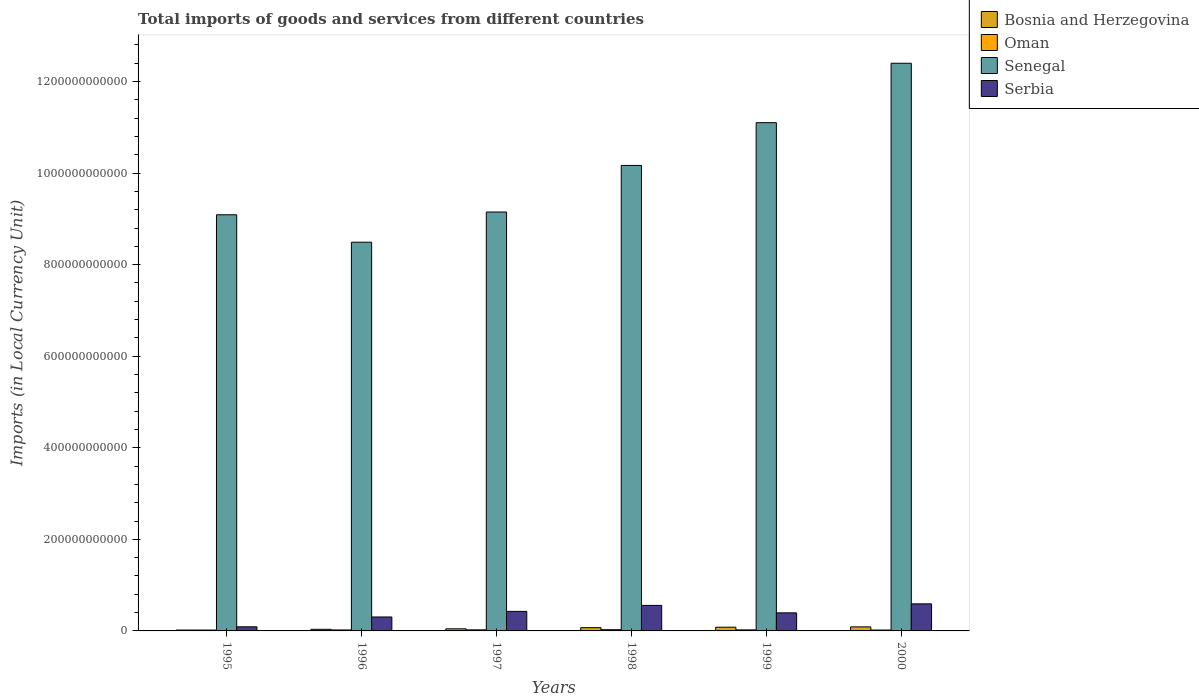How many different coloured bars are there?
Keep it short and to the point. 4. Are the number of bars on each tick of the X-axis equal?
Provide a short and direct response. Yes. How many bars are there on the 3rd tick from the left?
Offer a terse response. 4. What is the label of the 2nd group of bars from the left?
Offer a terse response. 1996. What is the Amount of goods and services imports in Bosnia and Herzegovina in 2000?
Make the answer very short. 8.83e+09. Across all years, what is the maximum Amount of goods and services imports in Senegal?
Make the answer very short. 1.24e+12. Across all years, what is the minimum Amount of goods and services imports in Bosnia and Herzegovina?
Your answer should be very brief. 1.91e+09. In which year was the Amount of goods and services imports in Serbia maximum?
Provide a short and direct response. 2000. In which year was the Amount of goods and services imports in Senegal minimum?
Provide a short and direct response. 1996. What is the total Amount of goods and services imports in Senegal in the graph?
Provide a succinct answer. 6.04e+12. What is the difference between the Amount of goods and services imports in Oman in 1997 and that in 1999?
Give a very brief answer. 8.10e+07. What is the difference between the Amount of goods and services imports in Serbia in 2000 and the Amount of goods and services imports in Bosnia and Herzegovina in 1999?
Make the answer very short. 5.10e+1. What is the average Amount of goods and services imports in Serbia per year?
Ensure brevity in your answer.  3.94e+1. In the year 1995, what is the difference between the Amount of goods and services imports in Serbia and Amount of goods and services imports in Oman?
Keep it short and to the point. 7.07e+09. What is the ratio of the Amount of goods and services imports in Oman in 1999 to that in 2000?
Your response must be concise. 1.17. Is the difference between the Amount of goods and services imports in Serbia in 1998 and 2000 greater than the difference between the Amount of goods and services imports in Oman in 1998 and 2000?
Offer a very short reply. No. What is the difference between the highest and the second highest Amount of goods and services imports in Serbia?
Offer a very short reply. 3.45e+09. What is the difference between the highest and the lowest Amount of goods and services imports in Senegal?
Ensure brevity in your answer.  3.91e+11. Is the sum of the Amount of goods and services imports in Serbia in 1997 and 1999 greater than the maximum Amount of goods and services imports in Oman across all years?
Keep it short and to the point. Yes. Is it the case that in every year, the sum of the Amount of goods and services imports in Oman and Amount of goods and services imports in Senegal is greater than the sum of Amount of goods and services imports in Serbia and Amount of goods and services imports in Bosnia and Herzegovina?
Your answer should be very brief. Yes. What does the 4th bar from the left in 1996 represents?
Offer a very short reply. Serbia. What does the 1st bar from the right in 2000 represents?
Offer a very short reply. Serbia. Is it the case that in every year, the sum of the Amount of goods and services imports in Bosnia and Herzegovina and Amount of goods and services imports in Oman is greater than the Amount of goods and services imports in Serbia?
Provide a succinct answer. No. How many bars are there?
Give a very brief answer. 24. Are all the bars in the graph horizontal?
Your answer should be compact. No. How many years are there in the graph?
Ensure brevity in your answer.  6. What is the difference between two consecutive major ticks on the Y-axis?
Offer a very short reply. 2.00e+11. Does the graph contain grids?
Your response must be concise. No. How many legend labels are there?
Offer a terse response. 4. What is the title of the graph?
Provide a short and direct response. Total imports of goods and services from different countries. Does "Pacific island small states" appear as one of the legend labels in the graph?
Your answer should be compact. No. What is the label or title of the X-axis?
Give a very brief answer. Years. What is the label or title of the Y-axis?
Provide a succinct answer. Imports (in Local Currency Unit). What is the Imports (in Local Currency Unit) of Bosnia and Herzegovina in 1995?
Ensure brevity in your answer.  1.91e+09. What is the Imports (in Local Currency Unit) of Oman in 1995?
Keep it short and to the point. 1.89e+09. What is the Imports (in Local Currency Unit) in Senegal in 1995?
Ensure brevity in your answer.  9.09e+11. What is the Imports (in Local Currency Unit) in Serbia in 1995?
Offer a terse response. 8.96e+09. What is the Imports (in Local Currency Unit) of Bosnia and Herzegovina in 1996?
Provide a short and direct response. 3.52e+09. What is the Imports (in Local Currency Unit) of Oman in 1996?
Your answer should be compact. 2.10e+09. What is the Imports (in Local Currency Unit) in Senegal in 1996?
Offer a terse response. 8.49e+11. What is the Imports (in Local Currency Unit) in Serbia in 1996?
Ensure brevity in your answer.  3.04e+1. What is the Imports (in Local Currency Unit) in Bosnia and Herzegovina in 1997?
Make the answer very short. 4.64e+09. What is the Imports (in Local Currency Unit) in Oman in 1997?
Provide a short and direct response. 2.35e+09. What is the Imports (in Local Currency Unit) of Senegal in 1997?
Offer a terse response. 9.15e+11. What is the Imports (in Local Currency Unit) in Serbia in 1997?
Provide a short and direct response. 4.27e+1. What is the Imports (in Local Currency Unit) of Bosnia and Herzegovina in 1998?
Offer a terse response. 7.13e+09. What is the Imports (in Local Currency Unit) in Oman in 1998?
Keep it short and to the point. 2.69e+09. What is the Imports (in Local Currency Unit) in Senegal in 1998?
Ensure brevity in your answer.  1.02e+12. What is the Imports (in Local Currency Unit) of Serbia in 1998?
Your answer should be very brief. 5.57e+1. What is the Imports (in Local Currency Unit) in Bosnia and Herzegovina in 1999?
Give a very brief answer. 8.10e+09. What is the Imports (in Local Currency Unit) of Oman in 1999?
Keep it short and to the point. 2.27e+09. What is the Imports (in Local Currency Unit) of Senegal in 1999?
Your answer should be very brief. 1.11e+12. What is the Imports (in Local Currency Unit) of Serbia in 1999?
Offer a very short reply. 3.95e+1. What is the Imports (in Local Currency Unit) in Bosnia and Herzegovina in 2000?
Your answer should be very brief. 8.83e+09. What is the Imports (in Local Currency Unit) of Oman in 2000?
Your response must be concise. 1.94e+09. What is the Imports (in Local Currency Unit) of Senegal in 2000?
Make the answer very short. 1.24e+12. What is the Imports (in Local Currency Unit) of Serbia in 2000?
Give a very brief answer. 5.91e+1. Across all years, what is the maximum Imports (in Local Currency Unit) of Bosnia and Herzegovina?
Give a very brief answer. 8.83e+09. Across all years, what is the maximum Imports (in Local Currency Unit) of Oman?
Offer a very short reply. 2.69e+09. Across all years, what is the maximum Imports (in Local Currency Unit) of Senegal?
Your answer should be compact. 1.24e+12. Across all years, what is the maximum Imports (in Local Currency Unit) in Serbia?
Ensure brevity in your answer.  5.91e+1. Across all years, what is the minimum Imports (in Local Currency Unit) of Bosnia and Herzegovina?
Ensure brevity in your answer.  1.91e+09. Across all years, what is the minimum Imports (in Local Currency Unit) in Oman?
Your answer should be compact. 1.89e+09. Across all years, what is the minimum Imports (in Local Currency Unit) of Senegal?
Provide a short and direct response. 8.49e+11. Across all years, what is the minimum Imports (in Local Currency Unit) in Serbia?
Keep it short and to the point. 8.96e+09. What is the total Imports (in Local Currency Unit) of Bosnia and Herzegovina in the graph?
Provide a succinct answer. 3.41e+1. What is the total Imports (in Local Currency Unit) in Oman in the graph?
Your answer should be very brief. 1.32e+1. What is the total Imports (in Local Currency Unit) of Senegal in the graph?
Your answer should be very brief. 6.04e+12. What is the total Imports (in Local Currency Unit) in Serbia in the graph?
Offer a terse response. 2.36e+11. What is the difference between the Imports (in Local Currency Unit) in Bosnia and Herzegovina in 1995 and that in 1996?
Provide a short and direct response. -1.60e+09. What is the difference between the Imports (in Local Currency Unit) in Oman in 1995 and that in 1996?
Offer a terse response. -2.14e+08. What is the difference between the Imports (in Local Currency Unit) of Senegal in 1995 and that in 1996?
Your answer should be very brief. 5.99e+1. What is the difference between the Imports (in Local Currency Unit) of Serbia in 1995 and that in 1996?
Make the answer very short. -2.15e+1. What is the difference between the Imports (in Local Currency Unit) in Bosnia and Herzegovina in 1995 and that in 1997?
Offer a very short reply. -2.72e+09. What is the difference between the Imports (in Local Currency Unit) in Oman in 1995 and that in 1997?
Offer a terse response. -4.63e+08. What is the difference between the Imports (in Local Currency Unit) in Senegal in 1995 and that in 1997?
Your answer should be compact. -6.03e+09. What is the difference between the Imports (in Local Currency Unit) of Serbia in 1995 and that in 1997?
Your answer should be compact. -3.37e+1. What is the difference between the Imports (in Local Currency Unit) in Bosnia and Herzegovina in 1995 and that in 1998?
Your answer should be compact. -5.21e+09. What is the difference between the Imports (in Local Currency Unit) of Oman in 1995 and that in 1998?
Offer a terse response. -8.06e+08. What is the difference between the Imports (in Local Currency Unit) of Senegal in 1995 and that in 1998?
Give a very brief answer. -1.08e+11. What is the difference between the Imports (in Local Currency Unit) in Serbia in 1995 and that in 1998?
Give a very brief answer. -4.67e+1. What is the difference between the Imports (in Local Currency Unit) of Bosnia and Herzegovina in 1995 and that in 1999?
Give a very brief answer. -6.19e+09. What is the difference between the Imports (in Local Currency Unit) of Oman in 1995 and that in 1999?
Provide a succinct answer. -3.82e+08. What is the difference between the Imports (in Local Currency Unit) in Senegal in 1995 and that in 1999?
Offer a terse response. -2.01e+11. What is the difference between the Imports (in Local Currency Unit) in Serbia in 1995 and that in 1999?
Provide a succinct answer. -3.05e+1. What is the difference between the Imports (in Local Currency Unit) in Bosnia and Herzegovina in 1995 and that in 2000?
Make the answer very short. -6.91e+09. What is the difference between the Imports (in Local Currency Unit) in Oman in 1995 and that in 2000?
Your answer should be very brief. -5.60e+07. What is the difference between the Imports (in Local Currency Unit) of Senegal in 1995 and that in 2000?
Keep it short and to the point. -3.31e+11. What is the difference between the Imports (in Local Currency Unit) in Serbia in 1995 and that in 2000?
Your answer should be compact. -5.02e+1. What is the difference between the Imports (in Local Currency Unit) in Bosnia and Herzegovina in 1996 and that in 1997?
Make the answer very short. -1.12e+09. What is the difference between the Imports (in Local Currency Unit) of Oman in 1996 and that in 1997?
Make the answer very short. -2.49e+08. What is the difference between the Imports (in Local Currency Unit) in Senegal in 1996 and that in 1997?
Your answer should be compact. -6.60e+1. What is the difference between the Imports (in Local Currency Unit) of Serbia in 1996 and that in 1997?
Offer a terse response. -1.22e+1. What is the difference between the Imports (in Local Currency Unit) of Bosnia and Herzegovina in 1996 and that in 1998?
Make the answer very short. -3.61e+09. What is the difference between the Imports (in Local Currency Unit) of Oman in 1996 and that in 1998?
Offer a terse response. -5.92e+08. What is the difference between the Imports (in Local Currency Unit) of Senegal in 1996 and that in 1998?
Provide a succinct answer. -1.68e+11. What is the difference between the Imports (in Local Currency Unit) in Serbia in 1996 and that in 1998?
Ensure brevity in your answer.  -2.53e+1. What is the difference between the Imports (in Local Currency Unit) in Bosnia and Herzegovina in 1996 and that in 1999?
Provide a short and direct response. -4.59e+09. What is the difference between the Imports (in Local Currency Unit) in Oman in 1996 and that in 1999?
Ensure brevity in your answer.  -1.68e+08. What is the difference between the Imports (in Local Currency Unit) of Senegal in 1996 and that in 1999?
Keep it short and to the point. -2.61e+11. What is the difference between the Imports (in Local Currency Unit) of Serbia in 1996 and that in 1999?
Provide a short and direct response. -9.02e+09. What is the difference between the Imports (in Local Currency Unit) of Bosnia and Herzegovina in 1996 and that in 2000?
Offer a terse response. -5.31e+09. What is the difference between the Imports (in Local Currency Unit) in Oman in 1996 and that in 2000?
Your answer should be very brief. 1.58e+08. What is the difference between the Imports (in Local Currency Unit) of Senegal in 1996 and that in 2000?
Offer a terse response. -3.91e+11. What is the difference between the Imports (in Local Currency Unit) in Serbia in 1996 and that in 2000?
Offer a very short reply. -2.87e+1. What is the difference between the Imports (in Local Currency Unit) of Bosnia and Herzegovina in 1997 and that in 1998?
Provide a succinct answer. -2.49e+09. What is the difference between the Imports (in Local Currency Unit) in Oman in 1997 and that in 1998?
Offer a terse response. -3.43e+08. What is the difference between the Imports (in Local Currency Unit) of Senegal in 1997 and that in 1998?
Provide a succinct answer. -1.02e+11. What is the difference between the Imports (in Local Currency Unit) in Serbia in 1997 and that in 1998?
Offer a terse response. -1.30e+1. What is the difference between the Imports (in Local Currency Unit) in Bosnia and Herzegovina in 1997 and that in 1999?
Provide a succinct answer. -3.47e+09. What is the difference between the Imports (in Local Currency Unit) in Oman in 1997 and that in 1999?
Your answer should be compact. 8.10e+07. What is the difference between the Imports (in Local Currency Unit) of Senegal in 1997 and that in 1999?
Your answer should be very brief. -1.95e+11. What is the difference between the Imports (in Local Currency Unit) of Serbia in 1997 and that in 1999?
Provide a short and direct response. 3.20e+09. What is the difference between the Imports (in Local Currency Unit) in Bosnia and Herzegovina in 1997 and that in 2000?
Offer a terse response. -4.19e+09. What is the difference between the Imports (in Local Currency Unit) in Oman in 1997 and that in 2000?
Offer a terse response. 4.07e+08. What is the difference between the Imports (in Local Currency Unit) of Senegal in 1997 and that in 2000?
Keep it short and to the point. -3.25e+11. What is the difference between the Imports (in Local Currency Unit) of Serbia in 1997 and that in 2000?
Your answer should be compact. -1.65e+1. What is the difference between the Imports (in Local Currency Unit) in Bosnia and Herzegovina in 1998 and that in 1999?
Make the answer very short. -9.76e+08. What is the difference between the Imports (in Local Currency Unit) of Oman in 1998 and that in 1999?
Offer a terse response. 4.24e+08. What is the difference between the Imports (in Local Currency Unit) in Senegal in 1998 and that in 1999?
Ensure brevity in your answer.  -9.34e+1. What is the difference between the Imports (in Local Currency Unit) in Serbia in 1998 and that in 1999?
Your answer should be compact. 1.62e+1. What is the difference between the Imports (in Local Currency Unit) of Bosnia and Herzegovina in 1998 and that in 2000?
Your response must be concise. -1.70e+09. What is the difference between the Imports (in Local Currency Unit) of Oman in 1998 and that in 2000?
Keep it short and to the point. 7.50e+08. What is the difference between the Imports (in Local Currency Unit) in Senegal in 1998 and that in 2000?
Give a very brief answer. -2.23e+11. What is the difference between the Imports (in Local Currency Unit) in Serbia in 1998 and that in 2000?
Your answer should be very brief. -3.45e+09. What is the difference between the Imports (in Local Currency Unit) of Bosnia and Herzegovina in 1999 and that in 2000?
Your answer should be compact. -7.23e+08. What is the difference between the Imports (in Local Currency Unit) in Oman in 1999 and that in 2000?
Provide a succinct answer. 3.26e+08. What is the difference between the Imports (in Local Currency Unit) in Senegal in 1999 and that in 2000?
Your response must be concise. -1.30e+11. What is the difference between the Imports (in Local Currency Unit) in Serbia in 1999 and that in 2000?
Your answer should be compact. -1.97e+1. What is the difference between the Imports (in Local Currency Unit) in Bosnia and Herzegovina in 1995 and the Imports (in Local Currency Unit) in Oman in 1996?
Keep it short and to the point. -1.89e+08. What is the difference between the Imports (in Local Currency Unit) in Bosnia and Herzegovina in 1995 and the Imports (in Local Currency Unit) in Senegal in 1996?
Provide a short and direct response. -8.47e+11. What is the difference between the Imports (in Local Currency Unit) of Bosnia and Herzegovina in 1995 and the Imports (in Local Currency Unit) of Serbia in 1996?
Your answer should be very brief. -2.85e+1. What is the difference between the Imports (in Local Currency Unit) of Oman in 1995 and the Imports (in Local Currency Unit) of Senegal in 1996?
Keep it short and to the point. -8.47e+11. What is the difference between the Imports (in Local Currency Unit) of Oman in 1995 and the Imports (in Local Currency Unit) of Serbia in 1996?
Ensure brevity in your answer.  -2.86e+1. What is the difference between the Imports (in Local Currency Unit) of Senegal in 1995 and the Imports (in Local Currency Unit) of Serbia in 1996?
Give a very brief answer. 8.79e+11. What is the difference between the Imports (in Local Currency Unit) of Bosnia and Herzegovina in 1995 and the Imports (in Local Currency Unit) of Oman in 1997?
Your response must be concise. -4.38e+08. What is the difference between the Imports (in Local Currency Unit) of Bosnia and Herzegovina in 1995 and the Imports (in Local Currency Unit) of Senegal in 1997?
Provide a short and direct response. -9.13e+11. What is the difference between the Imports (in Local Currency Unit) of Bosnia and Herzegovina in 1995 and the Imports (in Local Currency Unit) of Serbia in 1997?
Keep it short and to the point. -4.08e+1. What is the difference between the Imports (in Local Currency Unit) in Oman in 1995 and the Imports (in Local Currency Unit) in Senegal in 1997?
Give a very brief answer. -9.13e+11. What is the difference between the Imports (in Local Currency Unit) of Oman in 1995 and the Imports (in Local Currency Unit) of Serbia in 1997?
Give a very brief answer. -4.08e+1. What is the difference between the Imports (in Local Currency Unit) in Senegal in 1995 and the Imports (in Local Currency Unit) in Serbia in 1997?
Your response must be concise. 8.66e+11. What is the difference between the Imports (in Local Currency Unit) of Bosnia and Herzegovina in 1995 and the Imports (in Local Currency Unit) of Oman in 1998?
Offer a terse response. -7.81e+08. What is the difference between the Imports (in Local Currency Unit) in Bosnia and Herzegovina in 1995 and the Imports (in Local Currency Unit) in Senegal in 1998?
Your response must be concise. -1.01e+12. What is the difference between the Imports (in Local Currency Unit) in Bosnia and Herzegovina in 1995 and the Imports (in Local Currency Unit) in Serbia in 1998?
Make the answer very short. -5.38e+1. What is the difference between the Imports (in Local Currency Unit) of Oman in 1995 and the Imports (in Local Currency Unit) of Senegal in 1998?
Your response must be concise. -1.01e+12. What is the difference between the Imports (in Local Currency Unit) in Oman in 1995 and the Imports (in Local Currency Unit) in Serbia in 1998?
Your answer should be compact. -5.38e+1. What is the difference between the Imports (in Local Currency Unit) in Senegal in 1995 and the Imports (in Local Currency Unit) in Serbia in 1998?
Keep it short and to the point. 8.53e+11. What is the difference between the Imports (in Local Currency Unit) in Bosnia and Herzegovina in 1995 and the Imports (in Local Currency Unit) in Oman in 1999?
Your answer should be very brief. -3.57e+08. What is the difference between the Imports (in Local Currency Unit) of Bosnia and Herzegovina in 1995 and the Imports (in Local Currency Unit) of Senegal in 1999?
Make the answer very short. -1.11e+12. What is the difference between the Imports (in Local Currency Unit) in Bosnia and Herzegovina in 1995 and the Imports (in Local Currency Unit) in Serbia in 1999?
Your response must be concise. -3.76e+1. What is the difference between the Imports (in Local Currency Unit) in Oman in 1995 and the Imports (in Local Currency Unit) in Senegal in 1999?
Keep it short and to the point. -1.11e+12. What is the difference between the Imports (in Local Currency Unit) in Oman in 1995 and the Imports (in Local Currency Unit) in Serbia in 1999?
Offer a terse response. -3.76e+1. What is the difference between the Imports (in Local Currency Unit) of Senegal in 1995 and the Imports (in Local Currency Unit) of Serbia in 1999?
Give a very brief answer. 8.70e+11. What is the difference between the Imports (in Local Currency Unit) in Bosnia and Herzegovina in 1995 and the Imports (in Local Currency Unit) in Oman in 2000?
Provide a succinct answer. -3.12e+07. What is the difference between the Imports (in Local Currency Unit) of Bosnia and Herzegovina in 1995 and the Imports (in Local Currency Unit) of Senegal in 2000?
Offer a very short reply. -1.24e+12. What is the difference between the Imports (in Local Currency Unit) of Bosnia and Herzegovina in 1995 and the Imports (in Local Currency Unit) of Serbia in 2000?
Keep it short and to the point. -5.72e+1. What is the difference between the Imports (in Local Currency Unit) of Oman in 1995 and the Imports (in Local Currency Unit) of Senegal in 2000?
Keep it short and to the point. -1.24e+12. What is the difference between the Imports (in Local Currency Unit) of Oman in 1995 and the Imports (in Local Currency Unit) of Serbia in 2000?
Keep it short and to the point. -5.73e+1. What is the difference between the Imports (in Local Currency Unit) of Senegal in 1995 and the Imports (in Local Currency Unit) of Serbia in 2000?
Provide a short and direct response. 8.50e+11. What is the difference between the Imports (in Local Currency Unit) of Bosnia and Herzegovina in 1996 and the Imports (in Local Currency Unit) of Oman in 1997?
Provide a short and direct response. 1.17e+09. What is the difference between the Imports (in Local Currency Unit) in Bosnia and Herzegovina in 1996 and the Imports (in Local Currency Unit) in Senegal in 1997?
Your response must be concise. -9.12e+11. What is the difference between the Imports (in Local Currency Unit) in Bosnia and Herzegovina in 1996 and the Imports (in Local Currency Unit) in Serbia in 1997?
Your answer should be very brief. -3.91e+1. What is the difference between the Imports (in Local Currency Unit) of Oman in 1996 and the Imports (in Local Currency Unit) of Senegal in 1997?
Give a very brief answer. -9.13e+11. What is the difference between the Imports (in Local Currency Unit) of Oman in 1996 and the Imports (in Local Currency Unit) of Serbia in 1997?
Your answer should be compact. -4.06e+1. What is the difference between the Imports (in Local Currency Unit) of Senegal in 1996 and the Imports (in Local Currency Unit) of Serbia in 1997?
Offer a terse response. 8.06e+11. What is the difference between the Imports (in Local Currency Unit) in Bosnia and Herzegovina in 1996 and the Imports (in Local Currency Unit) in Oman in 1998?
Your answer should be compact. 8.24e+08. What is the difference between the Imports (in Local Currency Unit) of Bosnia and Herzegovina in 1996 and the Imports (in Local Currency Unit) of Senegal in 1998?
Provide a succinct answer. -1.01e+12. What is the difference between the Imports (in Local Currency Unit) of Bosnia and Herzegovina in 1996 and the Imports (in Local Currency Unit) of Serbia in 1998?
Your response must be concise. -5.22e+1. What is the difference between the Imports (in Local Currency Unit) in Oman in 1996 and the Imports (in Local Currency Unit) in Senegal in 1998?
Offer a terse response. -1.01e+12. What is the difference between the Imports (in Local Currency Unit) of Oman in 1996 and the Imports (in Local Currency Unit) of Serbia in 1998?
Ensure brevity in your answer.  -5.36e+1. What is the difference between the Imports (in Local Currency Unit) of Senegal in 1996 and the Imports (in Local Currency Unit) of Serbia in 1998?
Your answer should be very brief. 7.93e+11. What is the difference between the Imports (in Local Currency Unit) of Bosnia and Herzegovina in 1996 and the Imports (in Local Currency Unit) of Oman in 1999?
Offer a terse response. 1.25e+09. What is the difference between the Imports (in Local Currency Unit) of Bosnia and Herzegovina in 1996 and the Imports (in Local Currency Unit) of Senegal in 1999?
Give a very brief answer. -1.11e+12. What is the difference between the Imports (in Local Currency Unit) in Bosnia and Herzegovina in 1996 and the Imports (in Local Currency Unit) in Serbia in 1999?
Provide a succinct answer. -3.60e+1. What is the difference between the Imports (in Local Currency Unit) in Oman in 1996 and the Imports (in Local Currency Unit) in Senegal in 1999?
Your answer should be compact. -1.11e+12. What is the difference between the Imports (in Local Currency Unit) of Oman in 1996 and the Imports (in Local Currency Unit) of Serbia in 1999?
Keep it short and to the point. -3.74e+1. What is the difference between the Imports (in Local Currency Unit) in Senegal in 1996 and the Imports (in Local Currency Unit) in Serbia in 1999?
Give a very brief answer. 8.10e+11. What is the difference between the Imports (in Local Currency Unit) in Bosnia and Herzegovina in 1996 and the Imports (in Local Currency Unit) in Oman in 2000?
Make the answer very short. 1.57e+09. What is the difference between the Imports (in Local Currency Unit) in Bosnia and Herzegovina in 1996 and the Imports (in Local Currency Unit) in Senegal in 2000?
Your response must be concise. -1.24e+12. What is the difference between the Imports (in Local Currency Unit) in Bosnia and Herzegovina in 1996 and the Imports (in Local Currency Unit) in Serbia in 2000?
Offer a terse response. -5.56e+1. What is the difference between the Imports (in Local Currency Unit) of Oman in 1996 and the Imports (in Local Currency Unit) of Senegal in 2000?
Provide a succinct answer. -1.24e+12. What is the difference between the Imports (in Local Currency Unit) in Oman in 1996 and the Imports (in Local Currency Unit) in Serbia in 2000?
Your answer should be very brief. -5.70e+1. What is the difference between the Imports (in Local Currency Unit) of Senegal in 1996 and the Imports (in Local Currency Unit) of Serbia in 2000?
Provide a succinct answer. 7.90e+11. What is the difference between the Imports (in Local Currency Unit) of Bosnia and Herzegovina in 1997 and the Imports (in Local Currency Unit) of Oman in 1998?
Your answer should be very brief. 1.94e+09. What is the difference between the Imports (in Local Currency Unit) in Bosnia and Herzegovina in 1997 and the Imports (in Local Currency Unit) in Senegal in 1998?
Offer a terse response. -1.01e+12. What is the difference between the Imports (in Local Currency Unit) of Bosnia and Herzegovina in 1997 and the Imports (in Local Currency Unit) of Serbia in 1998?
Your response must be concise. -5.11e+1. What is the difference between the Imports (in Local Currency Unit) of Oman in 1997 and the Imports (in Local Currency Unit) of Senegal in 1998?
Provide a succinct answer. -1.01e+12. What is the difference between the Imports (in Local Currency Unit) in Oman in 1997 and the Imports (in Local Currency Unit) in Serbia in 1998?
Offer a terse response. -5.34e+1. What is the difference between the Imports (in Local Currency Unit) of Senegal in 1997 and the Imports (in Local Currency Unit) of Serbia in 1998?
Give a very brief answer. 8.59e+11. What is the difference between the Imports (in Local Currency Unit) in Bosnia and Herzegovina in 1997 and the Imports (in Local Currency Unit) in Oman in 1999?
Your response must be concise. 2.37e+09. What is the difference between the Imports (in Local Currency Unit) in Bosnia and Herzegovina in 1997 and the Imports (in Local Currency Unit) in Senegal in 1999?
Make the answer very short. -1.11e+12. What is the difference between the Imports (in Local Currency Unit) of Bosnia and Herzegovina in 1997 and the Imports (in Local Currency Unit) of Serbia in 1999?
Give a very brief answer. -3.48e+1. What is the difference between the Imports (in Local Currency Unit) in Oman in 1997 and the Imports (in Local Currency Unit) in Senegal in 1999?
Your response must be concise. -1.11e+12. What is the difference between the Imports (in Local Currency Unit) in Oman in 1997 and the Imports (in Local Currency Unit) in Serbia in 1999?
Give a very brief answer. -3.71e+1. What is the difference between the Imports (in Local Currency Unit) in Senegal in 1997 and the Imports (in Local Currency Unit) in Serbia in 1999?
Keep it short and to the point. 8.76e+11. What is the difference between the Imports (in Local Currency Unit) of Bosnia and Herzegovina in 1997 and the Imports (in Local Currency Unit) of Oman in 2000?
Keep it short and to the point. 2.69e+09. What is the difference between the Imports (in Local Currency Unit) of Bosnia and Herzegovina in 1997 and the Imports (in Local Currency Unit) of Senegal in 2000?
Make the answer very short. -1.24e+12. What is the difference between the Imports (in Local Currency Unit) in Bosnia and Herzegovina in 1997 and the Imports (in Local Currency Unit) in Serbia in 2000?
Offer a terse response. -5.45e+1. What is the difference between the Imports (in Local Currency Unit) in Oman in 1997 and the Imports (in Local Currency Unit) in Senegal in 2000?
Provide a short and direct response. -1.24e+12. What is the difference between the Imports (in Local Currency Unit) of Oman in 1997 and the Imports (in Local Currency Unit) of Serbia in 2000?
Provide a short and direct response. -5.68e+1. What is the difference between the Imports (in Local Currency Unit) in Senegal in 1997 and the Imports (in Local Currency Unit) in Serbia in 2000?
Give a very brief answer. 8.56e+11. What is the difference between the Imports (in Local Currency Unit) of Bosnia and Herzegovina in 1998 and the Imports (in Local Currency Unit) of Oman in 1999?
Offer a very short reply. 4.86e+09. What is the difference between the Imports (in Local Currency Unit) of Bosnia and Herzegovina in 1998 and the Imports (in Local Currency Unit) of Senegal in 1999?
Give a very brief answer. -1.10e+12. What is the difference between the Imports (in Local Currency Unit) of Bosnia and Herzegovina in 1998 and the Imports (in Local Currency Unit) of Serbia in 1999?
Your answer should be compact. -3.23e+1. What is the difference between the Imports (in Local Currency Unit) in Oman in 1998 and the Imports (in Local Currency Unit) in Senegal in 1999?
Your answer should be very brief. -1.11e+12. What is the difference between the Imports (in Local Currency Unit) in Oman in 1998 and the Imports (in Local Currency Unit) in Serbia in 1999?
Provide a short and direct response. -3.68e+1. What is the difference between the Imports (in Local Currency Unit) of Senegal in 1998 and the Imports (in Local Currency Unit) of Serbia in 1999?
Your response must be concise. 9.77e+11. What is the difference between the Imports (in Local Currency Unit) of Bosnia and Herzegovina in 1998 and the Imports (in Local Currency Unit) of Oman in 2000?
Your response must be concise. 5.18e+09. What is the difference between the Imports (in Local Currency Unit) in Bosnia and Herzegovina in 1998 and the Imports (in Local Currency Unit) in Senegal in 2000?
Provide a short and direct response. -1.23e+12. What is the difference between the Imports (in Local Currency Unit) in Bosnia and Herzegovina in 1998 and the Imports (in Local Currency Unit) in Serbia in 2000?
Ensure brevity in your answer.  -5.20e+1. What is the difference between the Imports (in Local Currency Unit) of Oman in 1998 and the Imports (in Local Currency Unit) of Senegal in 2000?
Provide a succinct answer. -1.24e+12. What is the difference between the Imports (in Local Currency Unit) of Oman in 1998 and the Imports (in Local Currency Unit) of Serbia in 2000?
Provide a succinct answer. -5.65e+1. What is the difference between the Imports (in Local Currency Unit) of Senegal in 1998 and the Imports (in Local Currency Unit) of Serbia in 2000?
Provide a short and direct response. 9.58e+11. What is the difference between the Imports (in Local Currency Unit) of Bosnia and Herzegovina in 1999 and the Imports (in Local Currency Unit) of Oman in 2000?
Offer a very short reply. 6.16e+09. What is the difference between the Imports (in Local Currency Unit) in Bosnia and Herzegovina in 1999 and the Imports (in Local Currency Unit) in Senegal in 2000?
Your answer should be very brief. -1.23e+12. What is the difference between the Imports (in Local Currency Unit) in Bosnia and Herzegovina in 1999 and the Imports (in Local Currency Unit) in Serbia in 2000?
Make the answer very short. -5.10e+1. What is the difference between the Imports (in Local Currency Unit) in Oman in 1999 and the Imports (in Local Currency Unit) in Senegal in 2000?
Offer a terse response. -1.24e+12. What is the difference between the Imports (in Local Currency Unit) in Oman in 1999 and the Imports (in Local Currency Unit) in Serbia in 2000?
Your answer should be very brief. -5.69e+1. What is the difference between the Imports (in Local Currency Unit) in Senegal in 1999 and the Imports (in Local Currency Unit) in Serbia in 2000?
Offer a terse response. 1.05e+12. What is the average Imports (in Local Currency Unit) in Bosnia and Herzegovina per year?
Your response must be concise. 5.69e+09. What is the average Imports (in Local Currency Unit) of Oman per year?
Your answer should be very brief. 2.21e+09. What is the average Imports (in Local Currency Unit) in Senegal per year?
Provide a short and direct response. 1.01e+12. What is the average Imports (in Local Currency Unit) in Serbia per year?
Your answer should be compact. 3.94e+1. In the year 1995, what is the difference between the Imports (in Local Currency Unit) in Bosnia and Herzegovina and Imports (in Local Currency Unit) in Oman?
Provide a short and direct response. 2.48e+07. In the year 1995, what is the difference between the Imports (in Local Currency Unit) in Bosnia and Herzegovina and Imports (in Local Currency Unit) in Senegal?
Your answer should be very brief. -9.07e+11. In the year 1995, what is the difference between the Imports (in Local Currency Unit) in Bosnia and Herzegovina and Imports (in Local Currency Unit) in Serbia?
Your answer should be very brief. -7.05e+09. In the year 1995, what is the difference between the Imports (in Local Currency Unit) of Oman and Imports (in Local Currency Unit) of Senegal?
Your answer should be very brief. -9.07e+11. In the year 1995, what is the difference between the Imports (in Local Currency Unit) in Oman and Imports (in Local Currency Unit) in Serbia?
Make the answer very short. -7.07e+09. In the year 1995, what is the difference between the Imports (in Local Currency Unit) in Senegal and Imports (in Local Currency Unit) in Serbia?
Keep it short and to the point. 9.00e+11. In the year 1996, what is the difference between the Imports (in Local Currency Unit) of Bosnia and Herzegovina and Imports (in Local Currency Unit) of Oman?
Make the answer very short. 1.42e+09. In the year 1996, what is the difference between the Imports (in Local Currency Unit) in Bosnia and Herzegovina and Imports (in Local Currency Unit) in Senegal?
Give a very brief answer. -8.46e+11. In the year 1996, what is the difference between the Imports (in Local Currency Unit) of Bosnia and Herzegovina and Imports (in Local Currency Unit) of Serbia?
Give a very brief answer. -2.69e+1. In the year 1996, what is the difference between the Imports (in Local Currency Unit) in Oman and Imports (in Local Currency Unit) in Senegal?
Provide a succinct answer. -8.47e+11. In the year 1996, what is the difference between the Imports (in Local Currency Unit) in Oman and Imports (in Local Currency Unit) in Serbia?
Give a very brief answer. -2.83e+1. In the year 1996, what is the difference between the Imports (in Local Currency Unit) of Senegal and Imports (in Local Currency Unit) of Serbia?
Your answer should be compact. 8.19e+11. In the year 1997, what is the difference between the Imports (in Local Currency Unit) of Bosnia and Herzegovina and Imports (in Local Currency Unit) of Oman?
Your answer should be compact. 2.29e+09. In the year 1997, what is the difference between the Imports (in Local Currency Unit) in Bosnia and Herzegovina and Imports (in Local Currency Unit) in Senegal?
Your response must be concise. -9.10e+11. In the year 1997, what is the difference between the Imports (in Local Currency Unit) in Bosnia and Herzegovina and Imports (in Local Currency Unit) in Serbia?
Make the answer very short. -3.80e+1. In the year 1997, what is the difference between the Imports (in Local Currency Unit) in Oman and Imports (in Local Currency Unit) in Senegal?
Ensure brevity in your answer.  -9.13e+11. In the year 1997, what is the difference between the Imports (in Local Currency Unit) of Oman and Imports (in Local Currency Unit) of Serbia?
Ensure brevity in your answer.  -4.03e+1. In the year 1997, what is the difference between the Imports (in Local Currency Unit) of Senegal and Imports (in Local Currency Unit) of Serbia?
Your answer should be compact. 8.72e+11. In the year 1998, what is the difference between the Imports (in Local Currency Unit) of Bosnia and Herzegovina and Imports (in Local Currency Unit) of Oman?
Your answer should be very brief. 4.43e+09. In the year 1998, what is the difference between the Imports (in Local Currency Unit) of Bosnia and Herzegovina and Imports (in Local Currency Unit) of Senegal?
Make the answer very short. -1.01e+12. In the year 1998, what is the difference between the Imports (in Local Currency Unit) of Bosnia and Herzegovina and Imports (in Local Currency Unit) of Serbia?
Your response must be concise. -4.86e+1. In the year 1998, what is the difference between the Imports (in Local Currency Unit) of Oman and Imports (in Local Currency Unit) of Senegal?
Offer a very short reply. -1.01e+12. In the year 1998, what is the difference between the Imports (in Local Currency Unit) in Oman and Imports (in Local Currency Unit) in Serbia?
Your response must be concise. -5.30e+1. In the year 1998, what is the difference between the Imports (in Local Currency Unit) of Senegal and Imports (in Local Currency Unit) of Serbia?
Your answer should be very brief. 9.61e+11. In the year 1999, what is the difference between the Imports (in Local Currency Unit) in Bosnia and Herzegovina and Imports (in Local Currency Unit) in Oman?
Offer a very short reply. 5.83e+09. In the year 1999, what is the difference between the Imports (in Local Currency Unit) in Bosnia and Herzegovina and Imports (in Local Currency Unit) in Senegal?
Ensure brevity in your answer.  -1.10e+12. In the year 1999, what is the difference between the Imports (in Local Currency Unit) in Bosnia and Herzegovina and Imports (in Local Currency Unit) in Serbia?
Give a very brief answer. -3.14e+1. In the year 1999, what is the difference between the Imports (in Local Currency Unit) in Oman and Imports (in Local Currency Unit) in Senegal?
Ensure brevity in your answer.  -1.11e+12. In the year 1999, what is the difference between the Imports (in Local Currency Unit) in Oman and Imports (in Local Currency Unit) in Serbia?
Provide a short and direct response. -3.72e+1. In the year 1999, what is the difference between the Imports (in Local Currency Unit) of Senegal and Imports (in Local Currency Unit) of Serbia?
Your answer should be compact. 1.07e+12. In the year 2000, what is the difference between the Imports (in Local Currency Unit) in Bosnia and Herzegovina and Imports (in Local Currency Unit) in Oman?
Provide a short and direct response. 6.88e+09. In the year 2000, what is the difference between the Imports (in Local Currency Unit) in Bosnia and Herzegovina and Imports (in Local Currency Unit) in Senegal?
Offer a terse response. -1.23e+12. In the year 2000, what is the difference between the Imports (in Local Currency Unit) in Bosnia and Herzegovina and Imports (in Local Currency Unit) in Serbia?
Offer a very short reply. -5.03e+1. In the year 2000, what is the difference between the Imports (in Local Currency Unit) in Oman and Imports (in Local Currency Unit) in Senegal?
Your response must be concise. -1.24e+12. In the year 2000, what is the difference between the Imports (in Local Currency Unit) of Oman and Imports (in Local Currency Unit) of Serbia?
Offer a terse response. -5.72e+1. In the year 2000, what is the difference between the Imports (in Local Currency Unit) of Senegal and Imports (in Local Currency Unit) of Serbia?
Give a very brief answer. 1.18e+12. What is the ratio of the Imports (in Local Currency Unit) in Bosnia and Herzegovina in 1995 to that in 1996?
Keep it short and to the point. 0.54. What is the ratio of the Imports (in Local Currency Unit) of Oman in 1995 to that in 1996?
Offer a terse response. 0.9. What is the ratio of the Imports (in Local Currency Unit) in Senegal in 1995 to that in 1996?
Your answer should be compact. 1.07. What is the ratio of the Imports (in Local Currency Unit) of Serbia in 1995 to that in 1996?
Give a very brief answer. 0.29. What is the ratio of the Imports (in Local Currency Unit) of Bosnia and Herzegovina in 1995 to that in 1997?
Provide a short and direct response. 0.41. What is the ratio of the Imports (in Local Currency Unit) in Oman in 1995 to that in 1997?
Your answer should be compact. 0.8. What is the ratio of the Imports (in Local Currency Unit) of Senegal in 1995 to that in 1997?
Offer a very short reply. 0.99. What is the ratio of the Imports (in Local Currency Unit) of Serbia in 1995 to that in 1997?
Provide a succinct answer. 0.21. What is the ratio of the Imports (in Local Currency Unit) of Bosnia and Herzegovina in 1995 to that in 1998?
Provide a short and direct response. 0.27. What is the ratio of the Imports (in Local Currency Unit) of Oman in 1995 to that in 1998?
Ensure brevity in your answer.  0.7. What is the ratio of the Imports (in Local Currency Unit) of Senegal in 1995 to that in 1998?
Your response must be concise. 0.89. What is the ratio of the Imports (in Local Currency Unit) of Serbia in 1995 to that in 1998?
Your response must be concise. 0.16. What is the ratio of the Imports (in Local Currency Unit) of Bosnia and Herzegovina in 1995 to that in 1999?
Your answer should be compact. 0.24. What is the ratio of the Imports (in Local Currency Unit) of Oman in 1995 to that in 1999?
Give a very brief answer. 0.83. What is the ratio of the Imports (in Local Currency Unit) of Senegal in 1995 to that in 1999?
Make the answer very short. 0.82. What is the ratio of the Imports (in Local Currency Unit) in Serbia in 1995 to that in 1999?
Offer a very short reply. 0.23. What is the ratio of the Imports (in Local Currency Unit) of Bosnia and Herzegovina in 1995 to that in 2000?
Your answer should be very brief. 0.22. What is the ratio of the Imports (in Local Currency Unit) of Oman in 1995 to that in 2000?
Provide a succinct answer. 0.97. What is the ratio of the Imports (in Local Currency Unit) in Senegal in 1995 to that in 2000?
Make the answer very short. 0.73. What is the ratio of the Imports (in Local Currency Unit) in Serbia in 1995 to that in 2000?
Provide a succinct answer. 0.15. What is the ratio of the Imports (in Local Currency Unit) of Bosnia and Herzegovina in 1996 to that in 1997?
Your answer should be compact. 0.76. What is the ratio of the Imports (in Local Currency Unit) in Oman in 1996 to that in 1997?
Ensure brevity in your answer.  0.89. What is the ratio of the Imports (in Local Currency Unit) in Senegal in 1996 to that in 1997?
Your response must be concise. 0.93. What is the ratio of the Imports (in Local Currency Unit) in Serbia in 1996 to that in 1997?
Give a very brief answer. 0.71. What is the ratio of the Imports (in Local Currency Unit) in Bosnia and Herzegovina in 1996 to that in 1998?
Offer a very short reply. 0.49. What is the ratio of the Imports (in Local Currency Unit) in Oman in 1996 to that in 1998?
Provide a succinct answer. 0.78. What is the ratio of the Imports (in Local Currency Unit) in Senegal in 1996 to that in 1998?
Your answer should be compact. 0.84. What is the ratio of the Imports (in Local Currency Unit) in Serbia in 1996 to that in 1998?
Ensure brevity in your answer.  0.55. What is the ratio of the Imports (in Local Currency Unit) in Bosnia and Herzegovina in 1996 to that in 1999?
Give a very brief answer. 0.43. What is the ratio of the Imports (in Local Currency Unit) in Oman in 1996 to that in 1999?
Ensure brevity in your answer.  0.93. What is the ratio of the Imports (in Local Currency Unit) of Senegal in 1996 to that in 1999?
Provide a short and direct response. 0.76. What is the ratio of the Imports (in Local Currency Unit) of Serbia in 1996 to that in 1999?
Give a very brief answer. 0.77. What is the ratio of the Imports (in Local Currency Unit) of Bosnia and Herzegovina in 1996 to that in 2000?
Provide a short and direct response. 0.4. What is the ratio of the Imports (in Local Currency Unit) of Oman in 1996 to that in 2000?
Your answer should be very brief. 1.08. What is the ratio of the Imports (in Local Currency Unit) in Senegal in 1996 to that in 2000?
Offer a terse response. 0.68. What is the ratio of the Imports (in Local Currency Unit) of Serbia in 1996 to that in 2000?
Provide a short and direct response. 0.51. What is the ratio of the Imports (in Local Currency Unit) of Bosnia and Herzegovina in 1997 to that in 1998?
Make the answer very short. 0.65. What is the ratio of the Imports (in Local Currency Unit) in Oman in 1997 to that in 1998?
Provide a short and direct response. 0.87. What is the ratio of the Imports (in Local Currency Unit) of Senegal in 1997 to that in 1998?
Your response must be concise. 0.9. What is the ratio of the Imports (in Local Currency Unit) in Serbia in 1997 to that in 1998?
Your response must be concise. 0.77. What is the ratio of the Imports (in Local Currency Unit) in Bosnia and Herzegovina in 1997 to that in 1999?
Your answer should be compact. 0.57. What is the ratio of the Imports (in Local Currency Unit) in Oman in 1997 to that in 1999?
Keep it short and to the point. 1.04. What is the ratio of the Imports (in Local Currency Unit) of Senegal in 1997 to that in 1999?
Your response must be concise. 0.82. What is the ratio of the Imports (in Local Currency Unit) in Serbia in 1997 to that in 1999?
Provide a succinct answer. 1.08. What is the ratio of the Imports (in Local Currency Unit) in Bosnia and Herzegovina in 1997 to that in 2000?
Your answer should be compact. 0.53. What is the ratio of the Imports (in Local Currency Unit) of Oman in 1997 to that in 2000?
Your response must be concise. 1.21. What is the ratio of the Imports (in Local Currency Unit) in Senegal in 1997 to that in 2000?
Ensure brevity in your answer.  0.74. What is the ratio of the Imports (in Local Currency Unit) of Serbia in 1997 to that in 2000?
Your answer should be very brief. 0.72. What is the ratio of the Imports (in Local Currency Unit) in Bosnia and Herzegovina in 1998 to that in 1999?
Offer a terse response. 0.88. What is the ratio of the Imports (in Local Currency Unit) in Oman in 1998 to that in 1999?
Provide a succinct answer. 1.19. What is the ratio of the Imports (in Local Currency Unit) of Senegal in 1998 to that in 1999?
Your response must be concise. 0.92. What is the ratio of the Imports (in Local Currency Unit) of Serbia in 1998 to that in 1999?
Keep it short and to the point. 1.41. What is the ratio of the Imports (in Local Currency Unit) in Bosnia and Herzegovina in 1998 to that in 2000?
Your response must be concise. 0.81. What is the ratio of the Imports (in Local Currency Unit) of Oman in 1998 to that in 2000?
Provide a succinct answer. 1.39. What is the ratio of the Imports (in Local Currency Unit) of Senegal in 1998 to that in 2000?
Give a very brief answer. 0.82. What is the ratio of the Imports (in Local Currency Unit) of Serbia in 1998 to that in 2000?
Make the answer very short. 0.94. What is the ratio of the Imports (in Local Currency Unit) in Bosnia and Herzegovina in 1999 to that in 2000?
Give a very brief answer. 0.92. What is the ratio of the Imports (in Local Currency Unit) in Oman in 1999 to that in 2000?
Ensure brevity in your answer.  1.17. What is the ratio of the Imports (in Local Currency Unit) of Senegal in 1999 to that in 2000?
Provide a short and direct response. 0.9. What is the ratio of the Imports (in Local Currency Unit) of Serbia in 1999 to that in 2000?
Offer a terse response. 0.67. What is the difference between the highest and the second highest Imports (in Local Currency Unit) in Bosnia and Herzegovina?
Your answer should be compact. 7.23e+08. What is the difference between the highest and the second highest Imports (in Local Currency Unit) of Oman?
Provide a succinct answer. 3.43e+08. What is the difference between the highest and the second highest Imports (in Local Currency Unit) in Senegal?
Your answer should be compact. 1.30e+11. What is the difference between the highest and the second highest Imports (in Local Currency Unit) of Serbia?
Offer a terse response. 3.45e+09. What is the difference between the highest and the lowest Imports (in Local Currency Unit) of Bosnia and Herzegovina?
Offer a terse response. 6.91e+09. What is the difference between the highest and the lowest Imports (in Local Currency Unit) of Oman?
Your response must be concise. 8.06e+08. What is the difference between the highest and the lowest Imports (in Local Currency Unit) of Senegal?
Ensure brevity in your answer.  3.91e+11. What is the difference between the highest and the lowest Imports (in Local Currency Unit) in Serbia?
Your response must be concise. 5.02e+1. 